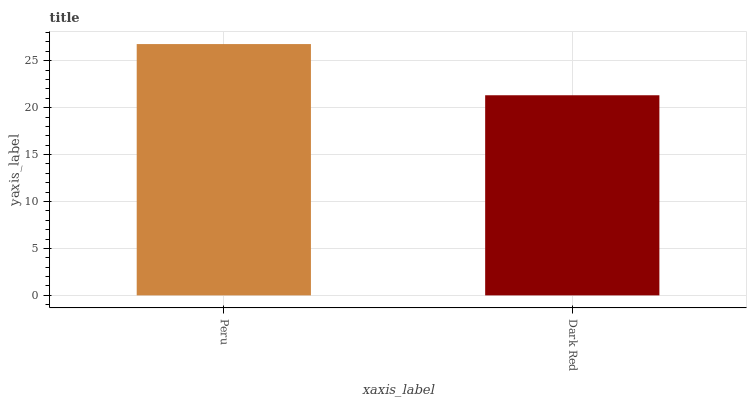Is Dark Red the minimum?
Answer yes or no. Yes. Is Peru the maximum?
Answer yes or no. Yes. Is Dark Red the maximum?
Answer yes or no. No. Is Peru greater than Dark Red?
Answer yes or no. Yes. Is Dark Red less than Peru?
Answer yes or no. Yes. Is Dark Red greater than Peru?
Answer yes or no. No. Is Peru less than Dark Red?
Answer yes or no. No. Is Peru the high median?
Answer yes or no. Yes. Is Dark Red the low median?
Answer yes or no. Yes. Is Dark Red the high median?
Answer yes or no. No. Is Peru the low median?
Answer yes or no. No. 